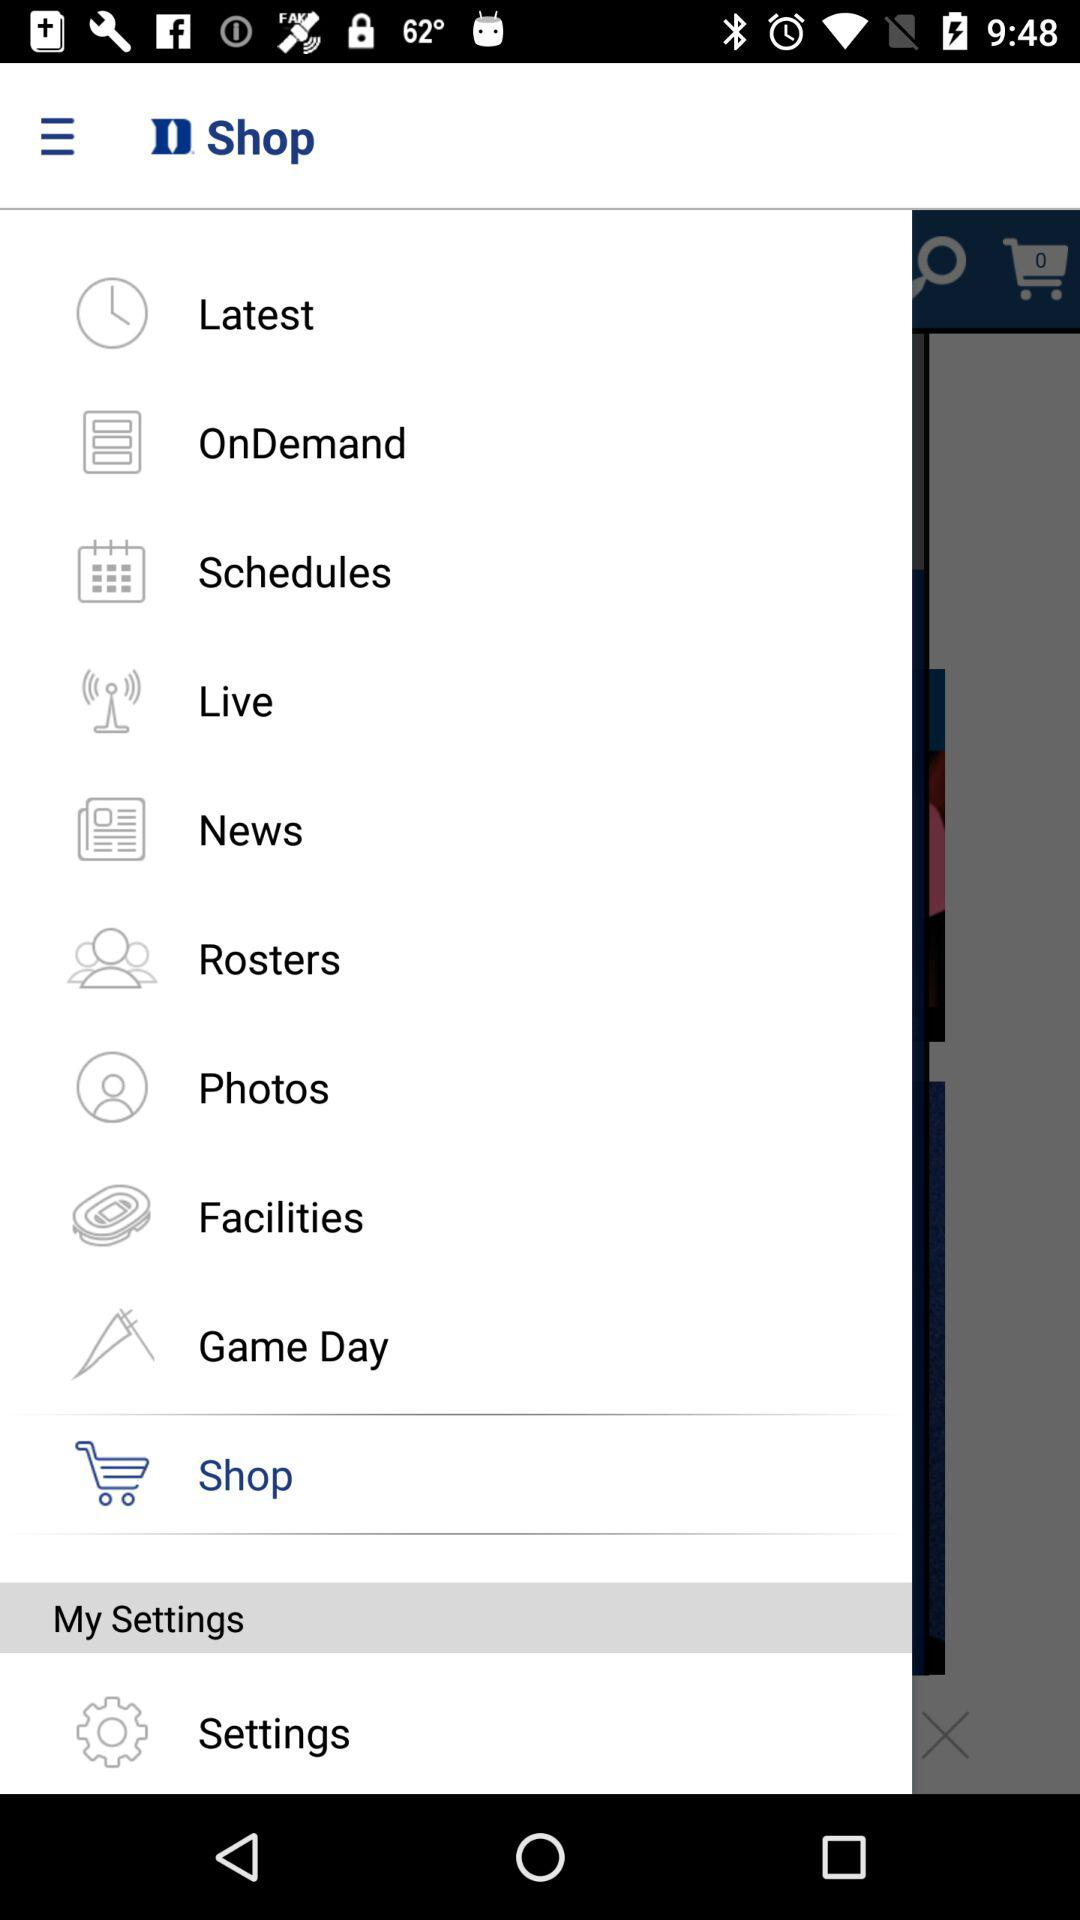How many photos have been uploaded?
When the provided information is insufficient, respond with <no answer>. <no answer> 